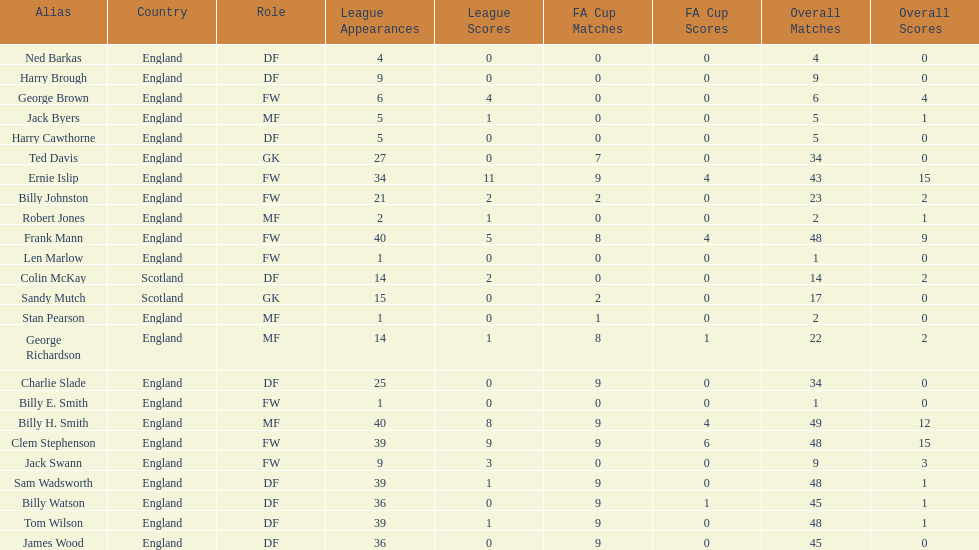What are the number of league apps ted davis has? 27. Help me parse the entirety of this table. {'header': ['Alias', 'Country', 'Role', 'League Appearances', 'League Scores', 'FA Cup Matches', 'FA Cup Scores', 'Overall Matches', 'Overall Scores'], 'rows': [['Ned Barkas', 'England', 'DF', '4', '0', '0', '0', '4', '0'], ['Harry Brough', 'England', 'DF', '9', '0', '0', '0', '9', '0'], ['George Brown', 'England', 'FW', '6', '4', '0', '0', '6', '4'], ['Jack Byers', 'England', 'MF', '5', '1', '0', '0', '5', '1'], ['Harry Cawthorne', 'England', 'DF', '5', '0', '0', '0', '5', '0'], ['Ted Davis', 'England', 'GK', '27', '0', '7', '0', '34', '0'], ['Ernie Islip', 'England', 'FW', '34', '11', '9', '4', '43', '15'], ['Billy Johnston', 'England', 'FW', '21', '2', '2', '0', '23', '2'], ['Robert Jones', 'England', 'MF', '2', '1', '0', '0', '2', '1'], ['Frank Mann', 'England', 'FW', '40', '5', '8', '4', '48', '9'], ['Len Marlow', 'England', 'FW', '1', '0', '0', '0', '1', '0'], ['Colin McKay', 'Scotland', 'DF', '14', '2', '0', '0', '14', '2'], ['Sandy Mutch', 'Scotland', 'GK', '15', '0', '2', '0', '17', '0'], ['Stan Pearson', 'England', 'MF', '1', '0', '1', '0', '2', '0'], ['George Richardson', 'England', 'MF', '14', '1', '8', '1', '22', '2'], ['Charlie Slade', 'England', 'DF', '25', '0', '9', '0', '34', '0'], ['Billy E. Smith', 'England', 'FW', '1', '0', '0', '0', '1', '0'], ['Billy H. Smith', 'England', 'MF', '40', '8', '9', '4', '49', '12'], ['Clem Stephenson', 'England', 'FW', '39', '9', '9', '6', '48', '15'], ['Jack Swann', 'England', 'FW', '9', '3', '0', '0', '9', '3'], ['Sam Wadsworth', 'England', 'DF', '39', '1', '9', '0', '48', '1'], ['Billy Watson', 'England', 'DF', '36', '0', '9', '1', '45', '1'], ['Tom Wilson', 'England', 'DF', '39', '1', '9', '0', '48', '1'], ['James Wood', 'England', 'DF', '36', '0', '9', '0', '45', '0']]} 